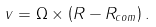<formula> <loc_0><loc_0><loc_500><loc_500>v = \Omega \times \left ( R - R _ { c o m } \right ) .</formula> 